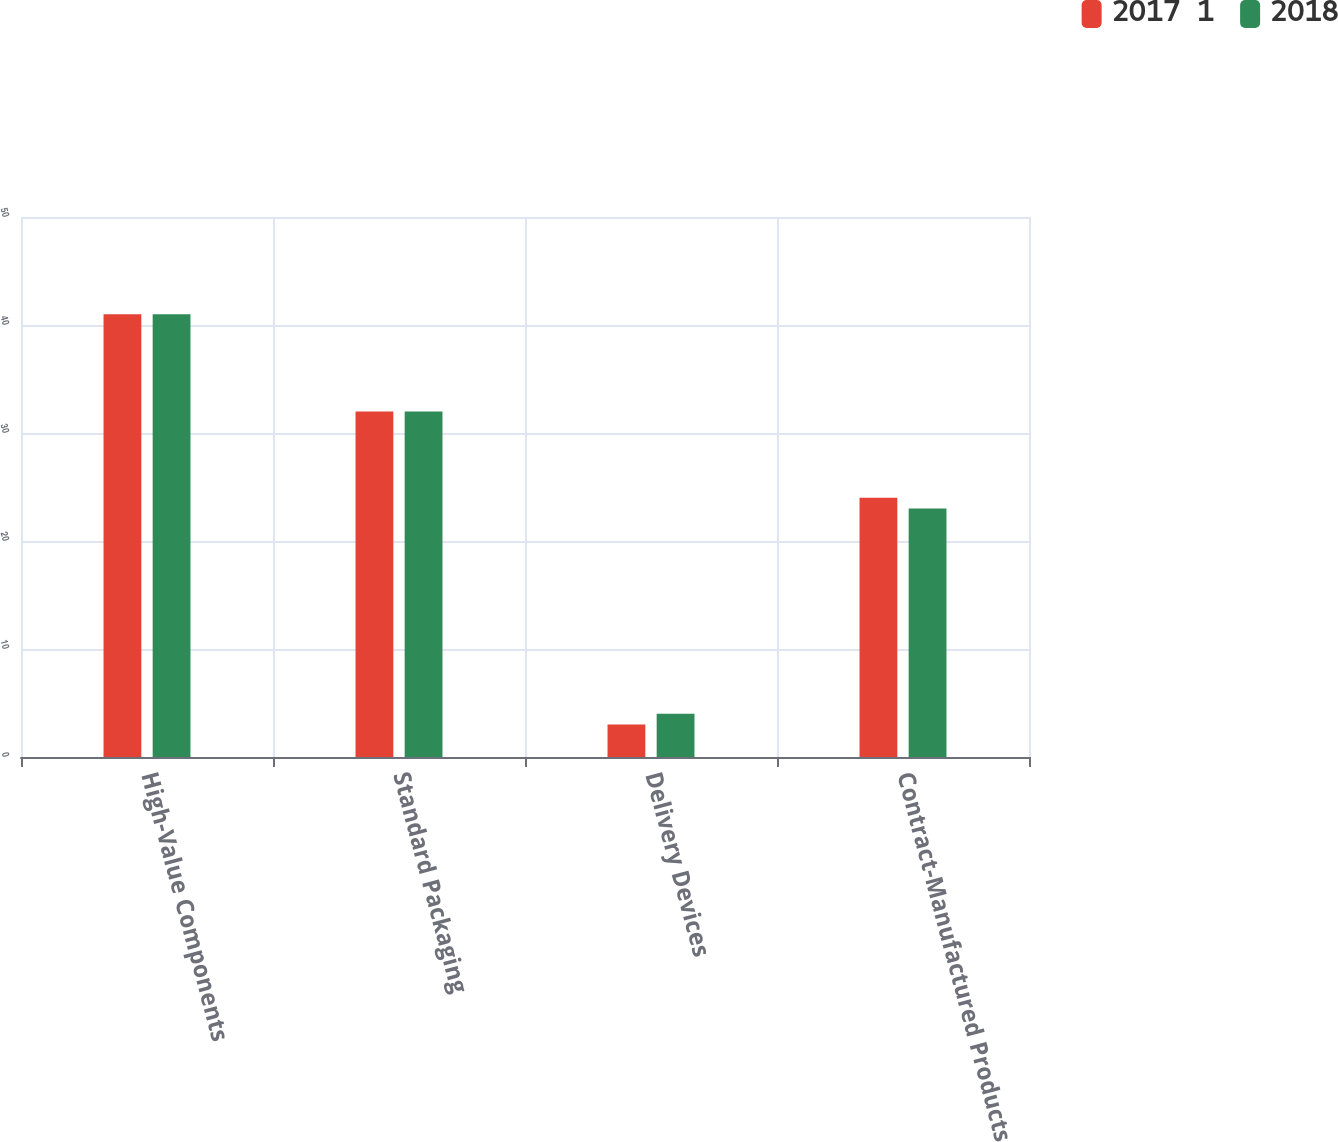<chart> <loc_0><loc_0><loc_500><loc_500><stacked_bar_chart><ecel><fcel>High-Value Components<fcel>Standard Packaging<fcel>Delivery Devices<fcel>Contract-Manufactured Products<nl><fcel>2017  1<fcel>41<fcel>32<fcel>3<fcel>24<nl><fcel>2018<fcel>41<fcel>32<fcel>4<fcel>23<nl></chart> 